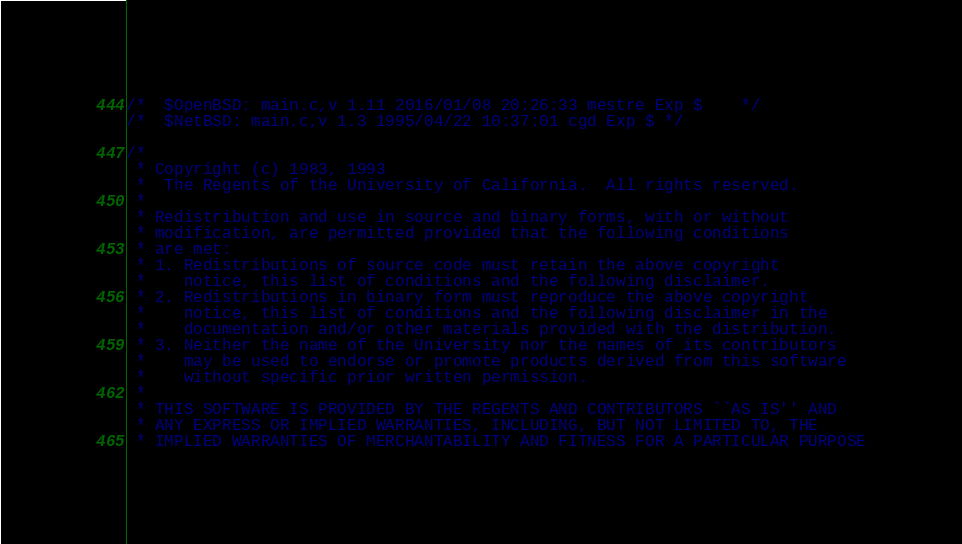Convert code to text. <code><loc_0><loc_0><loc_500><loc_500><_C_>/*	$OpenBSD: main.c,v 1.11 2016/01/08 20:26:33 mestre Exp $	*/
/*	$NetBSD: main.c,v 1.3 1995/04/22 10:37:01 cgd Exp $	*/

/*
 * Copyright (c) 1983, 1993
 *	The Regents of the University of California.  All rights reserved.
 *
 * Redistribution and use in source and binary forms, with or without
 * modification, are permitted provided that the following conditions
 * are met:
 * 1. Redistributions of source code must retain the above copyright
 *    notice, this list of conditions and the following disclaimer.
 * 2. Redistributions in binary form must reproduce the above copyright
 *    notice, this list of conditions and the following disclaimer in the
 *    documentation and/or other materials provided with the distribution.
 * 3. Neither the name of the University nor the names of its contributors
 *    may be used to endorse or promote products derived from this software
 *    without specific prior written permission.
 *
 * THIS SOFTWARE IS PROVIDED BY THE REGENTS AND CONTRIBUTORS ``AS IS'' AND
 * ANY EXPRESS OR IMPLIED WARRANTIES, INCLUDING, BUT NOT LIMITED TO, THE
 * IMPLIED WARRANTIES OF MERCHANTABILITY AND FITNESS FOR A PARTICULAR PURPOSE</code> 